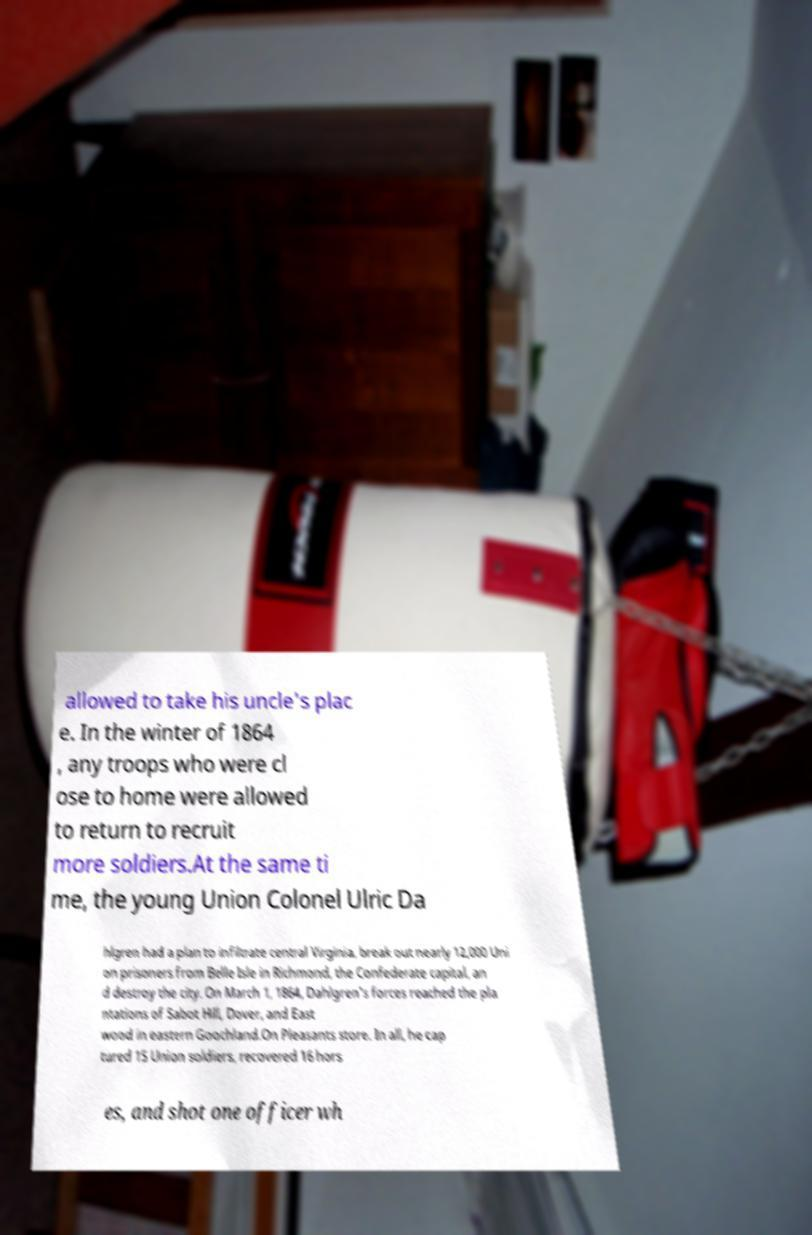There's text embedded in this image that I need extracted. Can you transcribe it verbatim? allowed to take his uncle's plac e. In the winter of 1864 , any troops who were cl ose to home were allowed to return to recruit more soldiers.At the same ti me, the young Union Colonel Ulric Da hlgren had a plan to infiltrate central Virginia, break out nearly 12,000 Uni on prisoners from Belle Isle in Richmond, the Confederate capital, an d destroy the city. On March 1, 1864, Dahlgren's forces reached the pla ntations of Sabot Hill, Dover, and East wood in eastern Goochland.On Pleasants store. In all, he cap tured 15 Union soldiers, recovered 16 hors es, and shot one officer wh 